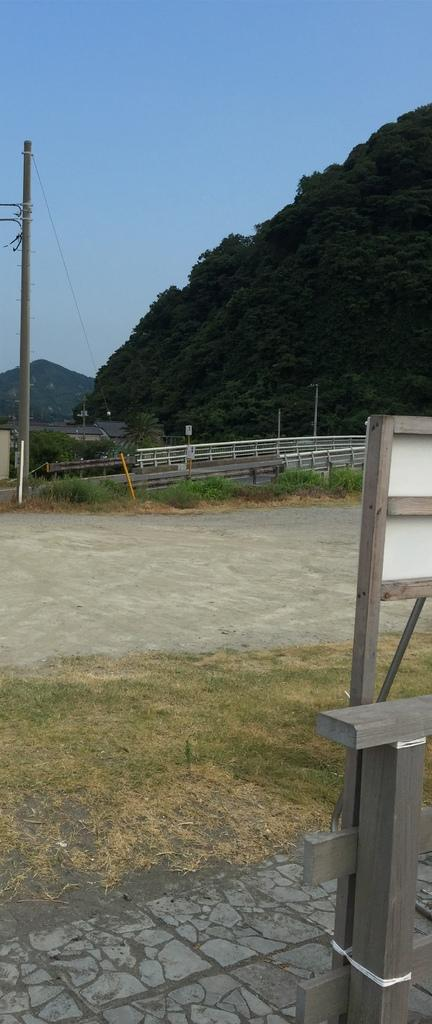What structures are present in the image? There are poles and a fence in the image. What type of buildings can be seen in the image? There are houses in the image. What other natural elements are present in the image? There are trees in the image. What is located on the right side of the image? There is a board on the right side of the image. What can be seen in the background of the image? There are hills visible in the background of the image. What type of riddle is written on the board in the image? There is no riddle written on the board in the image; it is just a plain board. Can you provide an example of a middle structure in the image? There is no middle structure in the image; the structures mentioned are poles and a fence. 